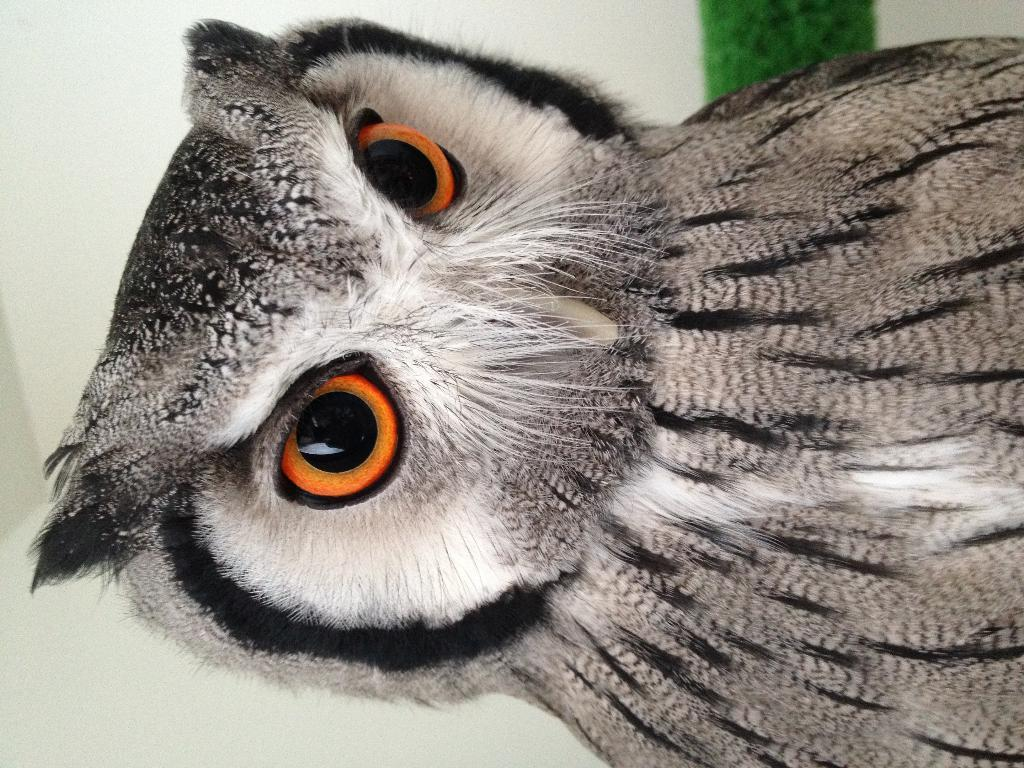What type of animal is in the picture? There is an owl in the picture. Can you describe the coloring of the owl? The owl has white, grey, and black coloring. What can be seen in the background of the image? There is a green color thing in the background of the image. What thought is the owl having in the image? There is no indication of the owl's thoughts in the image, as it is a photograph and not a representation of the owl's mental state. 